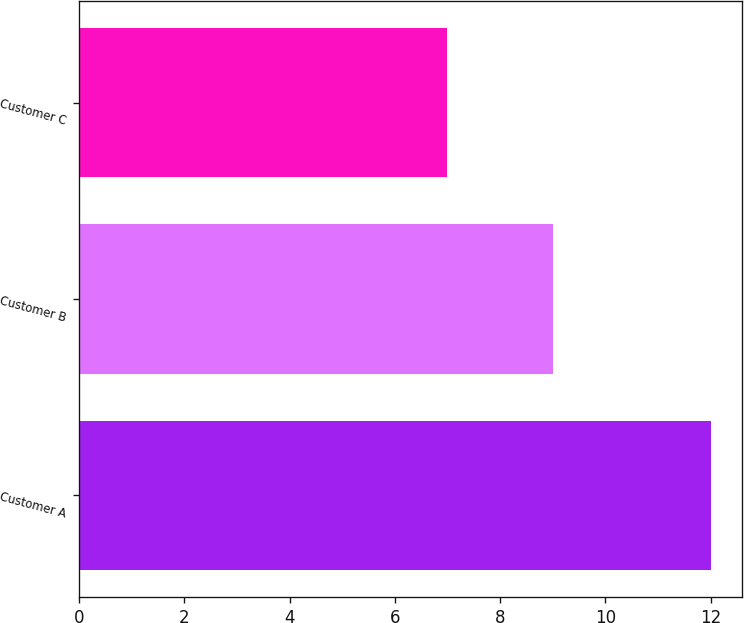<chart> <loc_0><loc_0><loc_500><loc_500><bar_chart><fcel>Customer A<fcel>Customer B<fcel>Customer C<nl><fcel>12<fcel>9<fcel>7<nl></chart> 